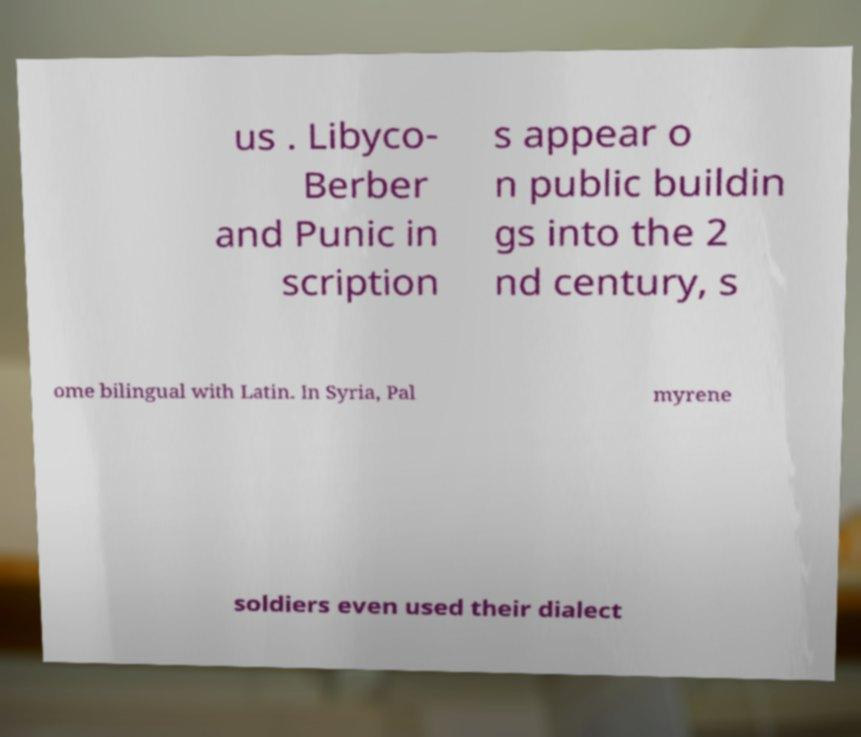Can you accurately transcribe the text from the provided image for me? us . Libyco- Berber and Punic in scription s appear o n public buildin gs into the 2 nd century, s ome bilingual with Latin. In Syria, Pal myrene soldiers even used their dialect 